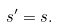<formula> <loc_0><loc_0><loc_500><loc_500>s ^ { \prime } = s .</formula> 